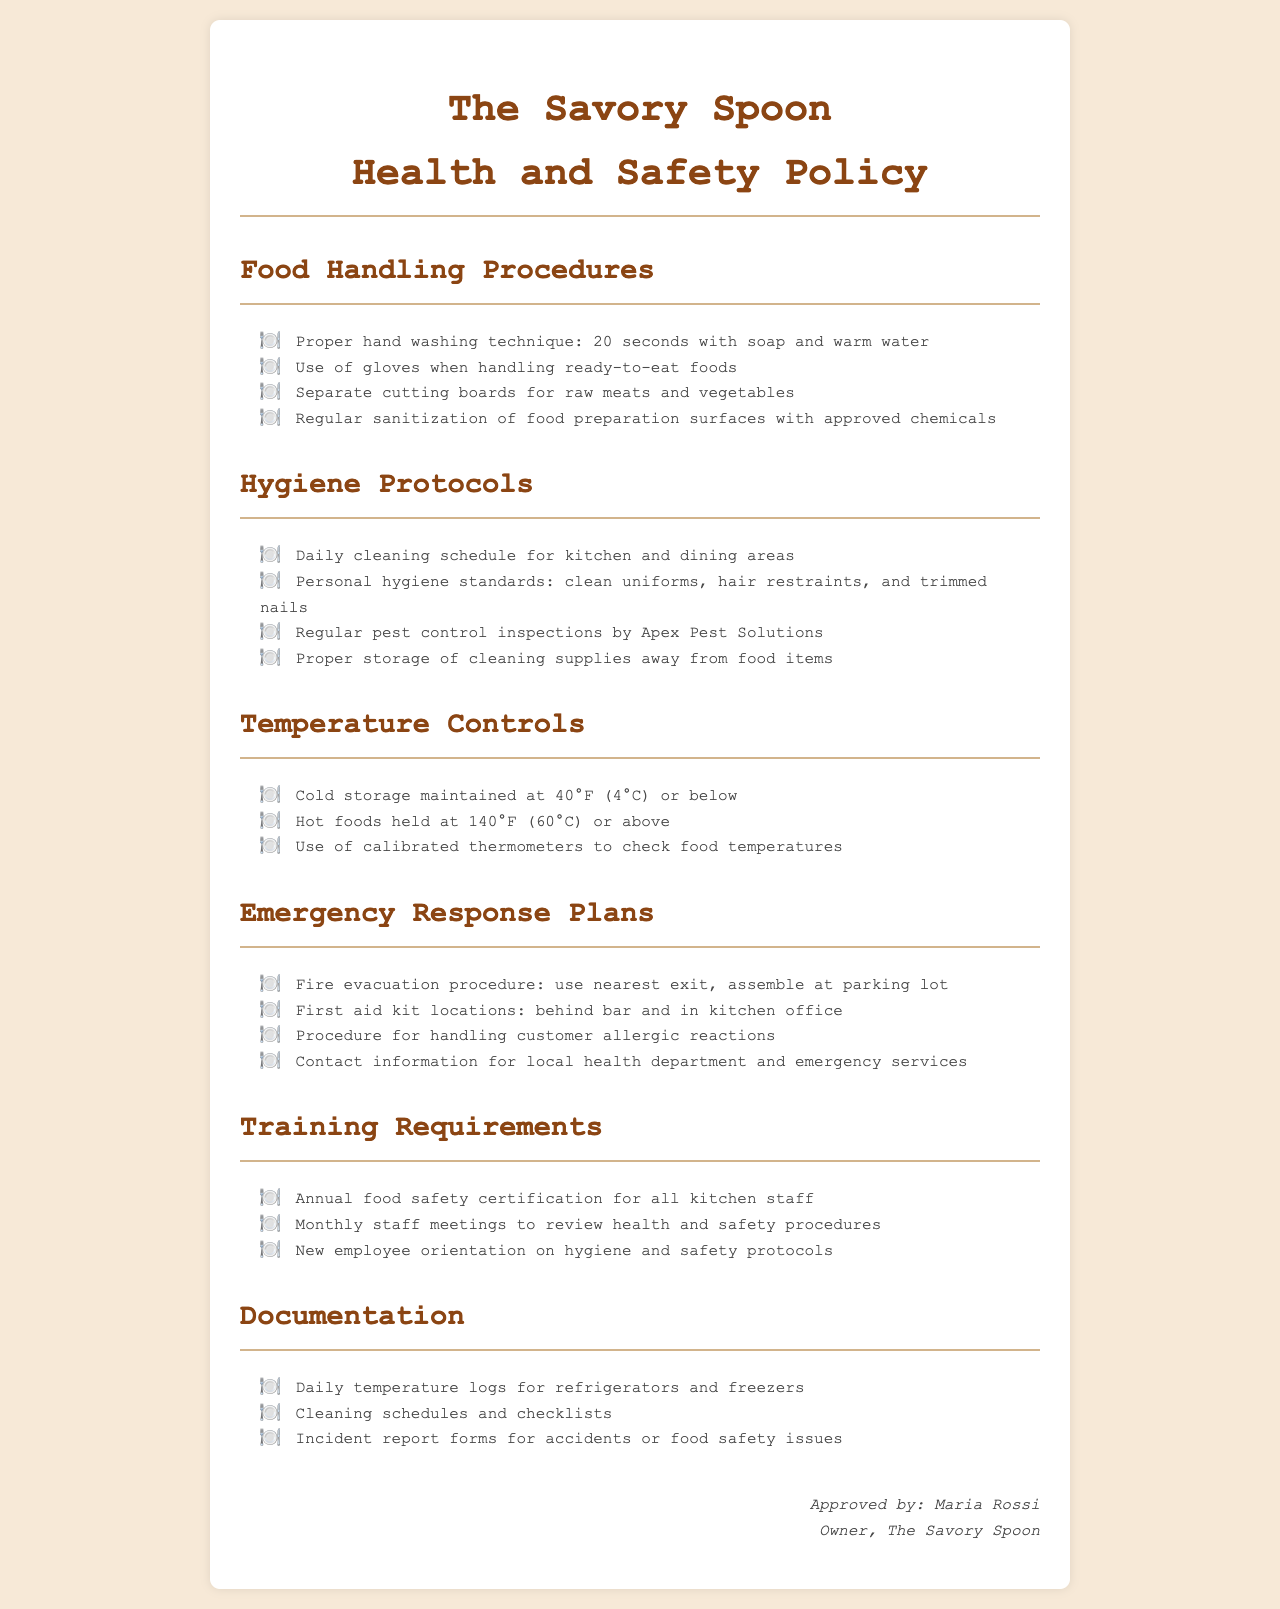What is the proper hand washing technique? The document states that the proper hand washing technique is 20 seconds with soap and warm water.
Answer: 20 seconds with soap and warm water What is the temperature for cold storage? The document mentions that cold storage should be maintained at 40°F (4°C) or below.
Answer: 40°F (4°C) or below Where can first aid kits be found? According to the document, first aid kits are located behind the bar and in the kitchen office.
Answer: Behind bar and in kitchen office What is the annual requirement for kitchen staff? The document specifies that annual food safety certification is required for all kitchen staff.
Answer: Annual food safety certification What is the daily cleaning schedule for? The document states that there is a daily cleaning schedule for kitchen and dining areas.
Answer: Kitchen and dining areas What is required for proper food handling? The proper food handling includes using gloves when handling ready-to-eat foods, as stated in the document.
Answer: Use of gloves when handling ready-to-eat foods What company conducts pest control inspections? The document specifies that pest control inspections are conducted by Apex Pest Solutions.
Answer: Apex Pest Solutions How often should staff meetings occur? The document states that monthly staff meetings are required to review health and safety procedures.
Answer: Monthly What is the procedure for handling allergic reactions? The document outlines that there is a procedure for handling customer allergic reactions.
Answer: Procedure for handling customer allergic reactions 